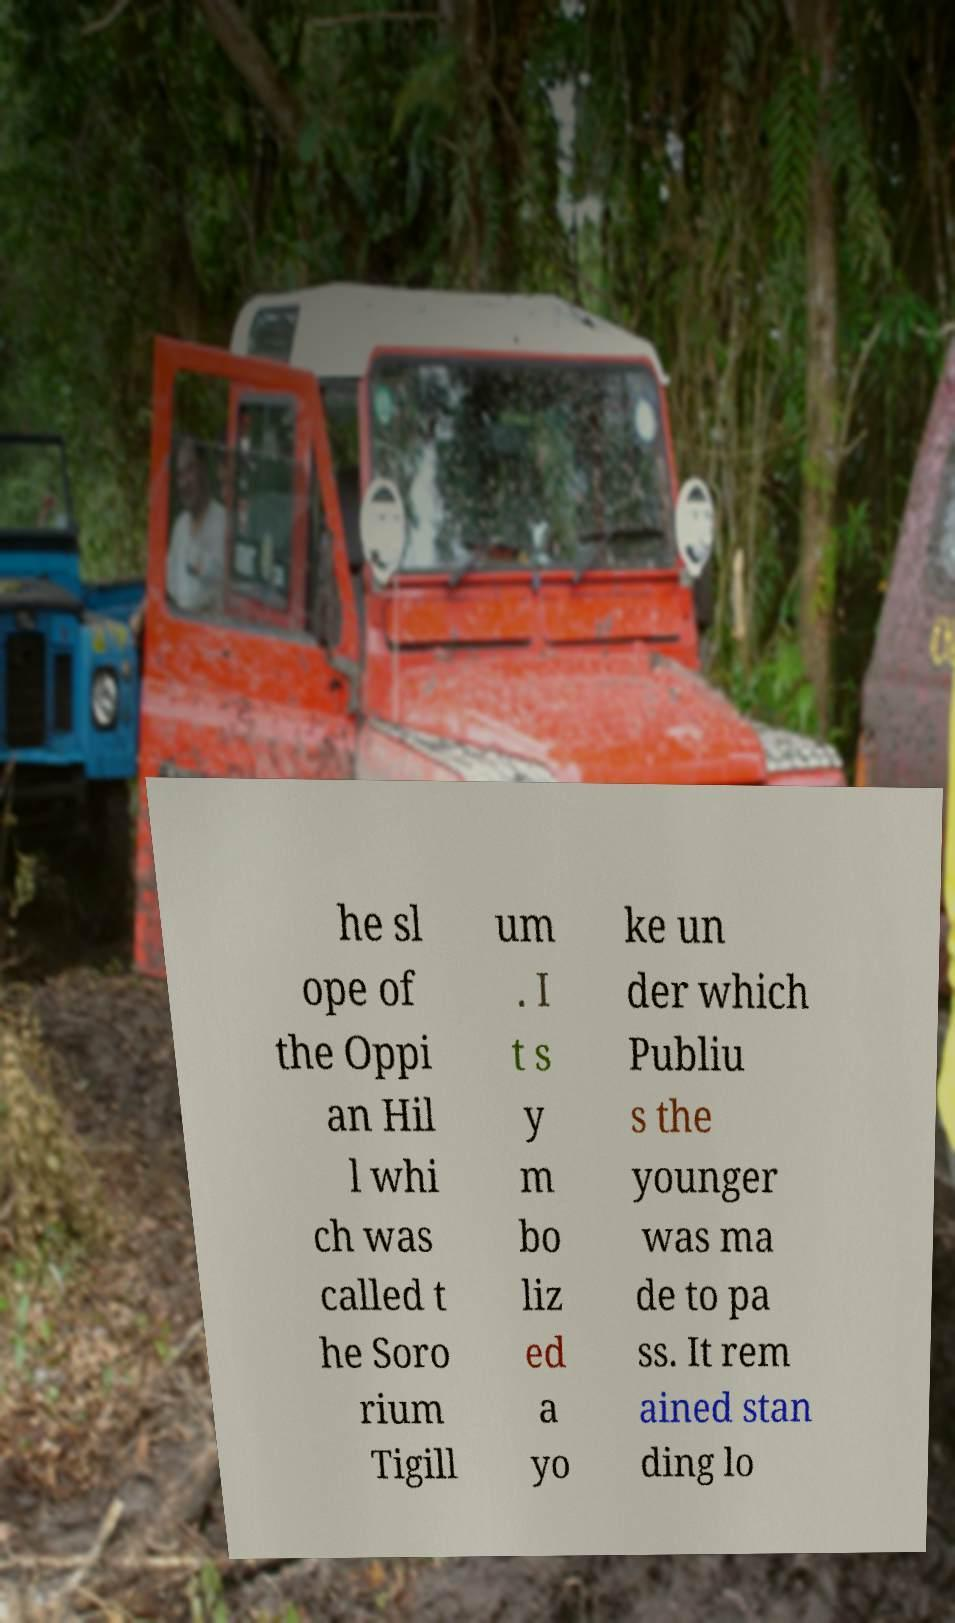What messages or text are displayed in this image? I need them in a readable, typed format. he sl ope of the Oppi an Hil l whi ch was called t he Soro rium Tigill um . I t s y m bo liz ed a yo ke un der which Publiu s the younger was ma de to pa ss. It rem ained stan ding lo 